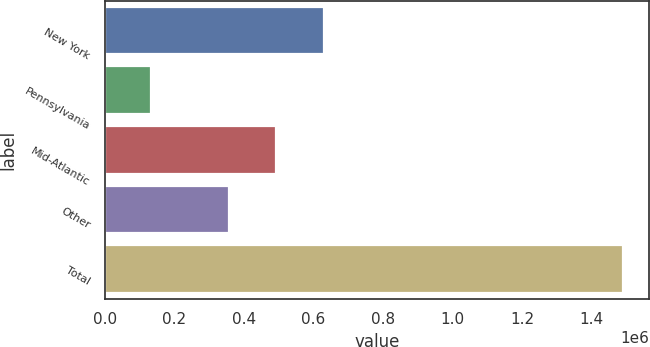Convert chart to OTSL. <chart><loc_0><loc_0><loc_500><loc_500><bar_chart><fcel>New York<fcel>Pennsylvania<fcel>Mid-Atlantic<fcel>Other<fcel>Total<nl><fcel>629487<fcel>133459<fcel>493698<fcel>357910<fcel>1.49134e+06<nl></chart> 